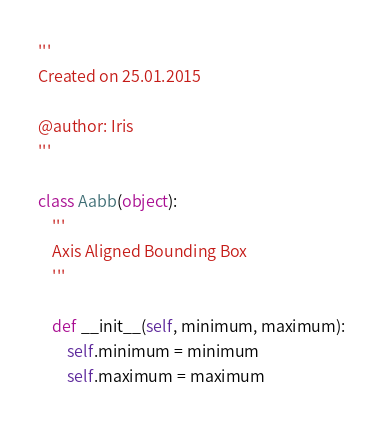Convert code to text. <code><loc_0><loc_0><loc_500><loc_500><_Python_>'''
Created on 25.01.2015

@author: Iris
'''

class Aabb(object):
    '''
    Axis Aligned Bounding Box
    '''

    def __init__(self, minimum, maximum):
        self.minimum = minimum
        self.maximum = maximum</code> 